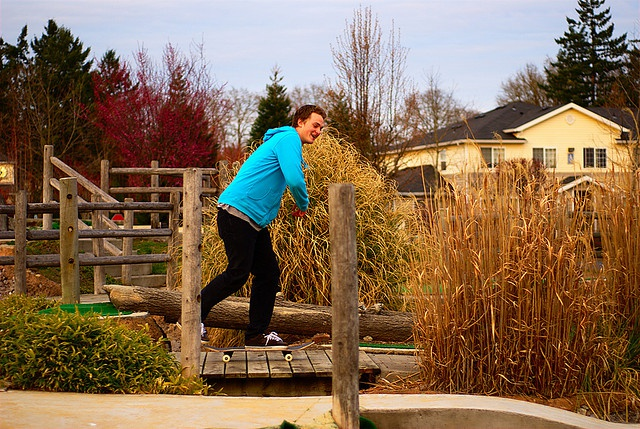Describe the objects in this image and their specific colors. I can see people in lavender, black, cyan, lightblue, and teal tones and skateboard in lavender, gray, black, tan, and khaki tones in this image. 